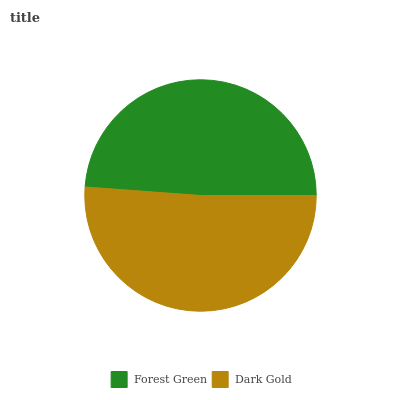Is Forest Green the minimum?
Answer yes or no. Yes. Is Dark Gold the maximum?
Answer yes or no. Yes. Is Dark Gold the minimum?
Answer yes or no. No. Is Dark Gold greater than Forest Green?
Answer yes or no. Yes. Is Forest Green less than Dark Gold?
Answer yes or no. Yes. Is Forest Green greater than Dark Gold?
Answer yes or no. No. Is Dark Gold less than Forest Green?
Answer yes or no. No. Is Dark Gold the high median?
Answer yes or no. Yes. Is Forest Green the low median?
Answer yes or no. Yes. Is Forest Green the high median?
Answer yes or no. No. Is Dark Gold the low median?
Answer yes or no. No. 